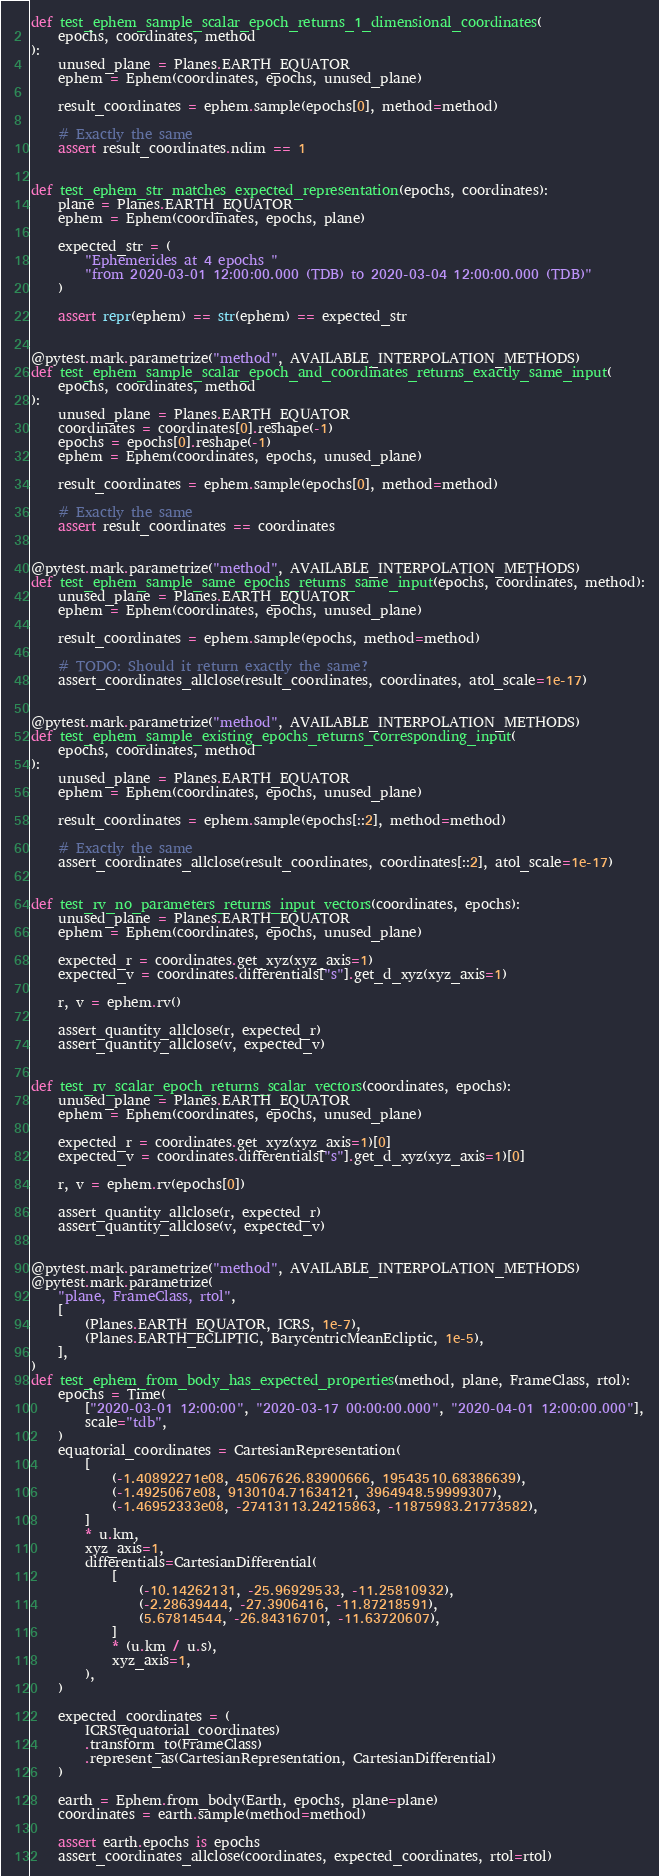Convert code to text. <code><loc_0><loc_0><loc_500><loc_500><_Python_>def test_ephem_sample_scalar_epoch_returns_1_dimensional_coordinates(
    epochs, coordinates, method
):
    unused_plane = Planes.EARTH_EQUATOR
    ephem = Ephem(coordinates, epochs, unused_plane)

    result_coordinates = ephem.sample(epochs[0], method=method)

    # Exactly the same
    assert result_coordinates.ndim == 1


def test_ephem_str_matches_expected_representation(epochs, coordinates):
    plane = Planes.EARTH_EQUATOR
    ephem = Ephem(coordinates, epochs, plane)

    expected_str = (
        "Ephemerides at 4 epochs "
        "from 2020-03-01 12:00:00.000 (TDB) to 2020-03-04 12:00:00.000 (TDB)"
    )

    assert repr(ephem) == str(ephem) == expected_str


@pytest.mark.parametrize("method", AVAILABLE_INTERPOLATION_METHODS)
def test_ephem_sample_scalar_epoch_and_coordinates_returns_exactly_same_input(
    epochs, coordinates, method
):
    unused_plane = Planes.EARTH_EQUATOR
    coordinates = coordinates[0].reshape(-1)
    epochs = epochs[0].reshape(-1)
    ephem = Ephem(coordinates, epochs, unused_plane)

    result_coordinates = ephem.sample(epochs[0], method=method)

    # Exactly the same
    assert result_coordinates == coordinates


@pytest.mark.parametrize("method", AVAILABLE_INTERPOLATION_METHODS)
def test_ephem_sample_same_epochs_returns_same_input(epochs, coordinates, method):
    unused_plane = Planes.EARTH_EQUATOR
    ephem = Ephem(coordinates, epochs, unused_plane)

    result_coordinates = ephem.sample(epochs, method=method)

    # TODO: Should it return exactly the same?
    assert_coordinates_allclose(result_coordinates, coordinates, atol_scale=1e-17)


@pytest.mark.parametrize("method", AVAILABLE_INTERPOLATION_METHODS)
def test_ephem_sample_existing_epochs_returns_corresponding_input(
    epochs, coordinates, method
):
    unused_plane = Planes.EARTH_EQUATOR
    ephem = Ephem(coordinates, epochs, unused_plane)

    result_coordinates = ephem.sample(epochs[::2], method=method)

    # Exactly the same
    assert_coordinates_allclose(result_coordinates, coordinates[::2], atol_scale=1e-17)


def test_rv_no_parameters_returns_input_vectors(coordinates, epochs):
    unused_plane = Planes.EARTH_EQUATOR
    ephem = Ephem(coordinates, epochs, unused_plane)

    expected_r = coordinates.get_xyz(xyz_axis=1)
    expected_v = coordinates.differentials["s"].get_d_xyz(xyz_axis=1)

    r, v = ephem.rv()

    assert_quantity_allclose(r, expected_r)
    assert_quantity_allclose(v, expected_v)


def test_rv_scalar_epoch_returns_scalar_vectors(coordinates, epochs):
    unused_plane = Planes.EARTH_EQUATOR
    ephem = Ephem(coordinates, epochs, unused_plane)

    expected_r = coordinates.get_xyz(xyz_axis=1)[0]
    expected_v = coordinates.differentials["s"].get_d_xyz(xyz_axis=1)[0]

    r, v = ephem.rv(epochs[0])

    assert_quantity_allclose(r, expected_r)
    assert_quantity_allclose(v, expected_v)


@pytest.mark.parametrize("method", AVAILABLE_INTERPOLATION_METHODS)
@pytest.mark.parametrize(
    "plane, FrameClass, rtol",
    [
        (Planes.EARTH_EQUATOR, ICRS, 1e-7),
        (Planes.EARTH_ECLIPTIC, BarycentricMeanEcliptic, 1e-5),
    ],
)
def test_ephem_from_body_has_expected_properties(method, plane, FrameClass, rtol):
    epochs = Time(
        ["2020-03-01 12:00:00", "2020-03-17 00:00:00.000", "2020-04-01 12:00:00.000"],
        scale="tdb",
    )
    equatorial_coordinates = CartesianRepresentation(
        [
            (-1.40892271e08, 45067626.83900666, 19543510.68386639),
            (-1.4925067e08, 9130104.71634121, 3964948.59999307),
            (-1.46952333e08, -27413113.24215863, -11875983.21773582),
        ]
        * u.km,
        xyz_axis=1,
        differentials=CartesianDifferential(
            [
                (-10.14262131, -25.96929533, -11.25810932),
                (-2.28639444, -27.3906416, -11.87218591),
                (5.67814544, -26.84316701, -11.63720607),
            ]
            * (u.km / u.s),
            xyz_axis=1,
        ),
    )

    expected_coordinates = (
        ICRS(equatorial_coordinates)
        .transform_to(FrameClass)
        .represent_as(CartesianRepresentation, CartesianDifferential)
    )

    earth = Ephem.from_body(Earth, epochs, plane=plane)
    coordinates = earth.sample(method=method)

    assert earth.epochs is epochs
    assert_coordinates_allclose(coordinates, expected_coordinates, rtol=rtol)

</code> 